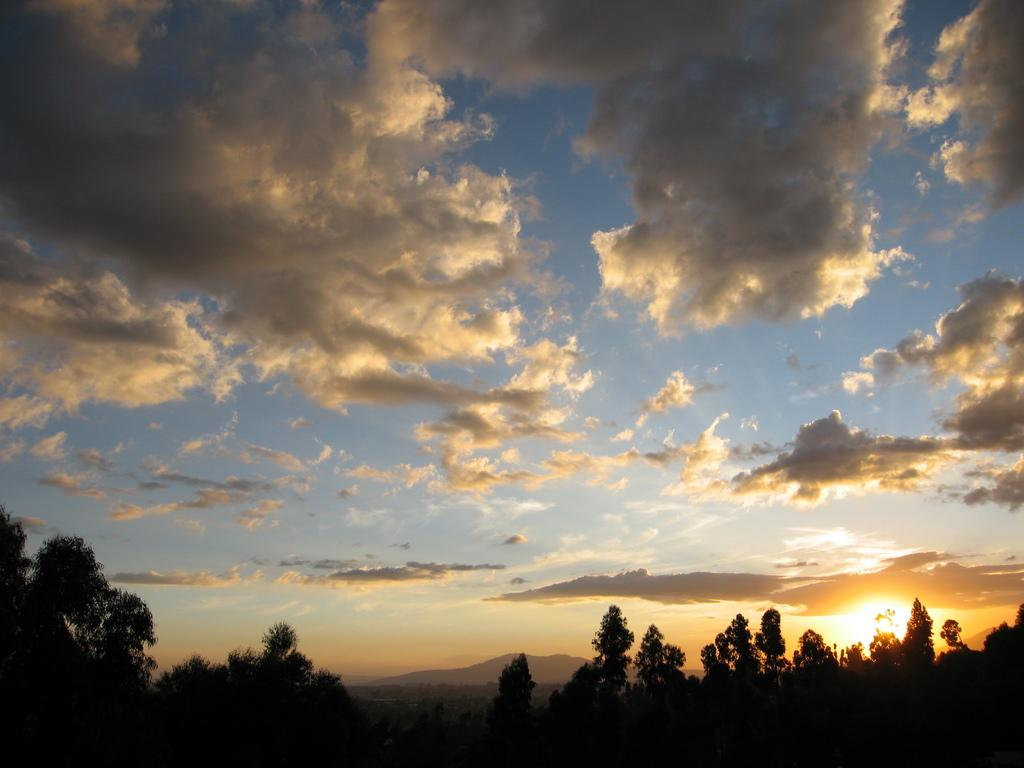What type of vegetation is at the bottom of the image? There are trees at the bottom of the image. What is visible at the top of the image? The sky is visible at the top of the image. What can be seen in the sky? There are clouds in the sky in the sky. Where is the sun located in the image? The sun is on the right side of the image, at the bottom. How long is the tail of the animal in the image? There is no animal with a tail present in the image; it features trees, sky, clouds, and a sun. What type of park is visible in the image? There is no park present in the image; it features trees, sky, clouds, and a sun. 